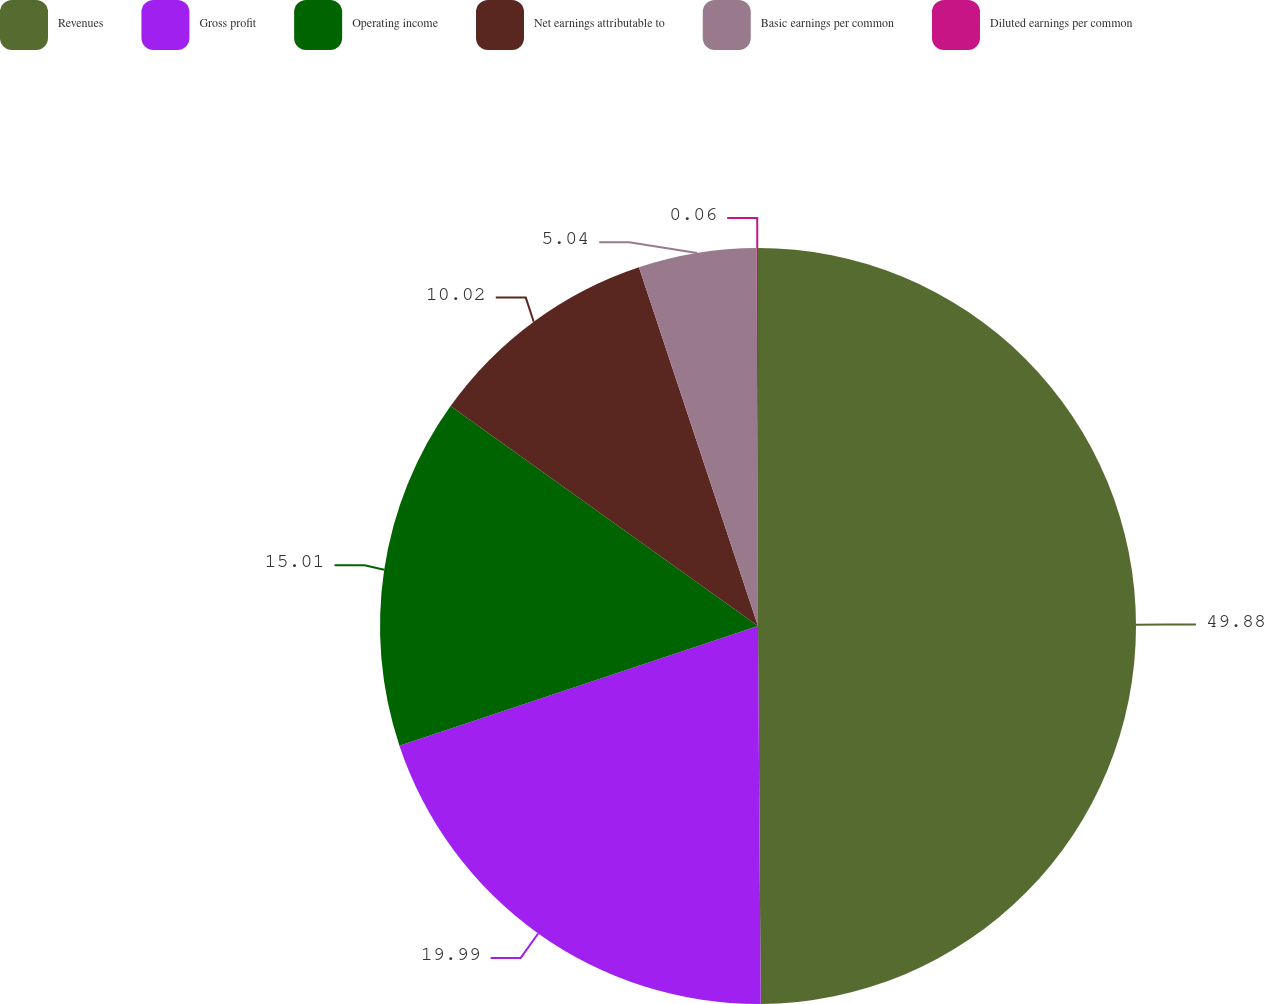<chart> <loc_0><loc_0><loc_500><loc_500><pie_chart><fcel>Revenues<fcel>Gross profit<fcel>Operating income<fcel>Net earnings attributable to<fcel>Basic earnings per common<fcel>Diluted earnings per common<nl><fcel>49.89%<fcel>19.99%<fcel>15.01%<fcel>10.02%<fcel>5.04%<fcel>0.06%<nl></chart> 